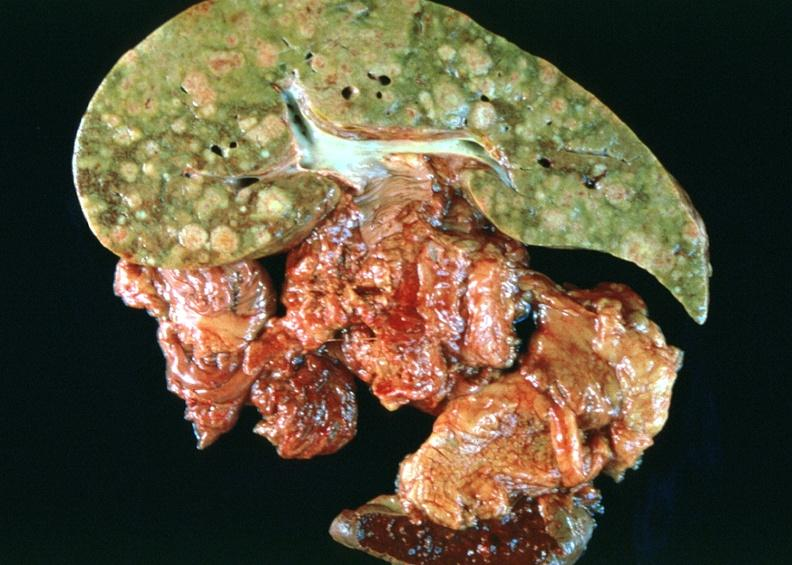s hepatobiliary present?
Answer the question using a single word or phrase. Yes 